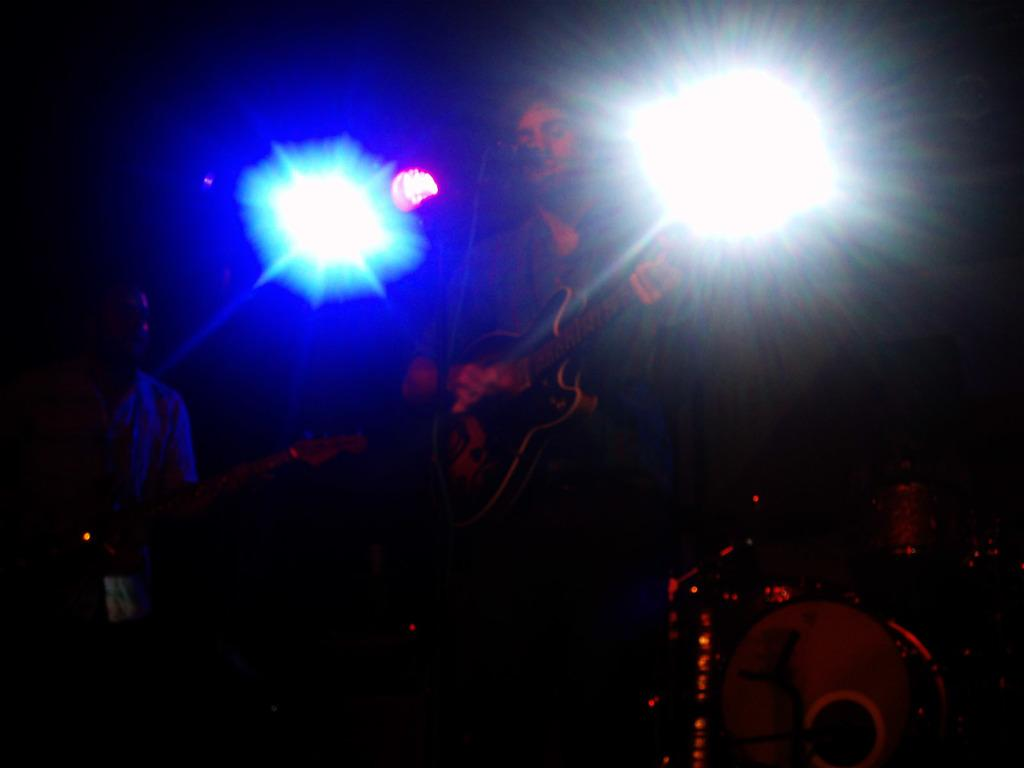How many people are in the image? There are two men in the image. What are the men holding in the image? The men are holding guitars. Are there any other musical instruments in the image besides the guitars? Yes, there are other musical instruments in the image. What can be seen in the background of the image? There are lights visible in the background of the image. What type of protest is happening in the image? There is no protest present in the image; it features two men holding guitars and other musical instruments. How does the crowd react to the afterthought in the image? There is no crowd or afterthought present in the image. 